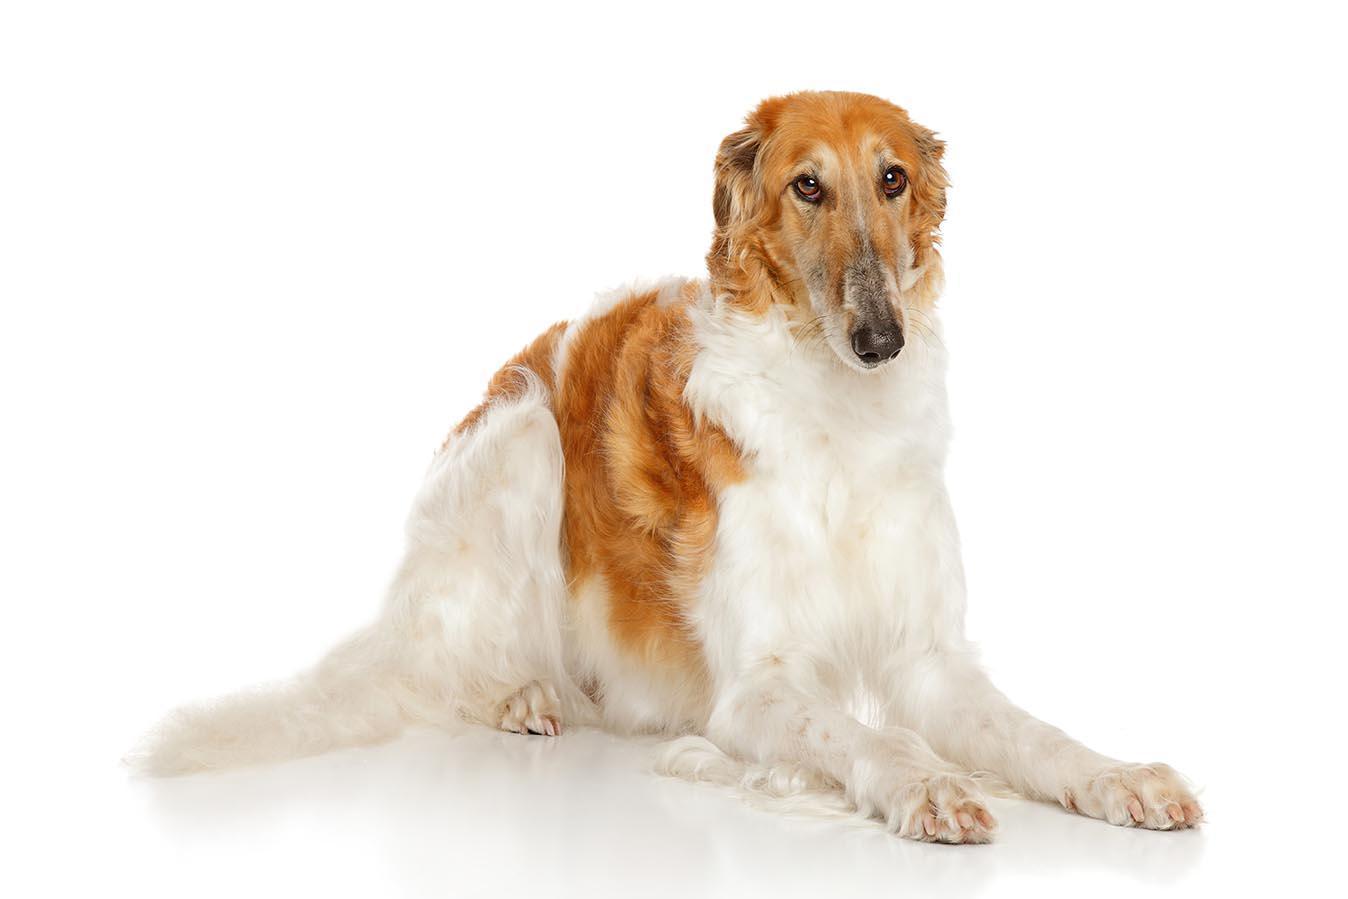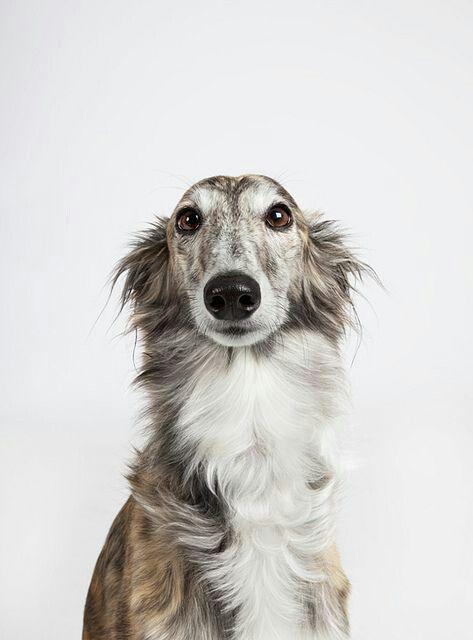The first image is the image on the left, the second image is the image on the right. For the images shown, is this caption "Both of the dogs are in similar body positions and with similar backgrounds." true? Answer yes or no. No. The first image is the image on the left, the second image is the image on the right. Given the left and right images, does the statement "The dog in the image on the left is lying down." hold true? Answer yes or no. Yes. 